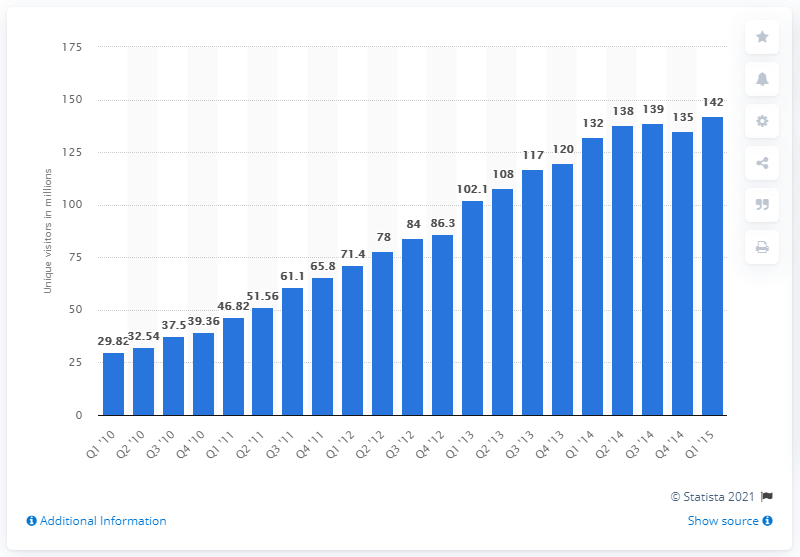Identify some key points in this picture. In the first quarter of 2015, Yelp.com had 142 unique visitors. 